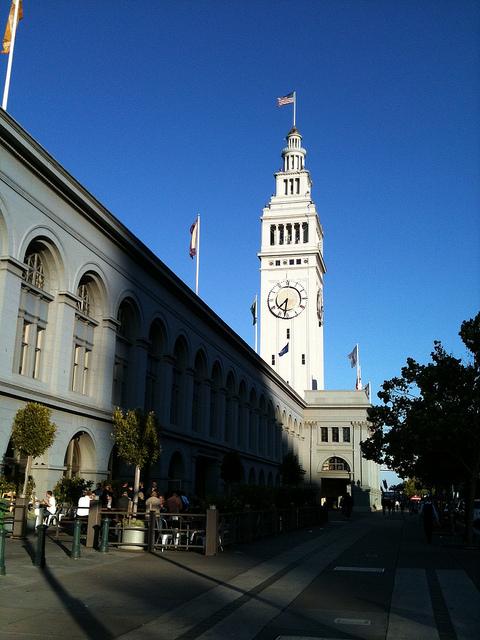Is this a church?
Quick response, please. No. What color are the seats?
Concise answer only. White. Is it sunny in the picture?
Write a very short answer. Yes. Is the road busy?
Answer briefly. No. How many people in this photo?
Quick response, please. 10. Is this a prison?
Quick response, please. No. Is there a US flag visible?
Answer briefly. Yes. What time is it?
Concise answer only. 7:30. Is there a plant in the plantar in front of the building?
Concise answer only. Yes. Is the sun shining?
Write a very short answer. Yes. Is there a watermark in this picture?
Quick response, please. No. How many people are shown?
Give a very brief answer. 10. Is this an example of modern architecture?
Keep it brief. No. 